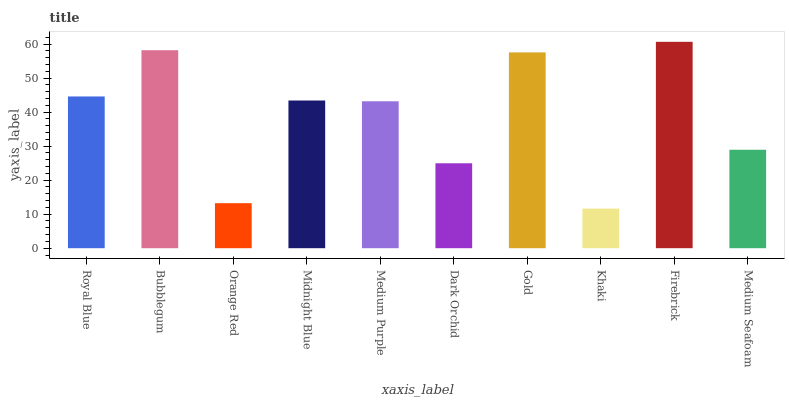Is Khaki the minimum?
Answer yes or no. Yes. Is Firebrick the maximum?
Answer yes or no. Yes. Is Bubblegum the minimum?
Answer yes or no. No. Is Bubblegum the maximum?
Answer yes or no. No. Is Bubblegum greater than Royal Blue?
Answer yes or no. Yes. Is Royal Blue less than Bubblegum?
Answer yes or no. Yes. Is Royal Blue greater than Bubblegum?
Answer yes or no. No. Is Bubblegum less than Royal Blue?
Answer yes or no. No. Is Midnight Blue the high median?
Answer yes or no. Yes. Is Medium Purple the low median?
Answer yes or no. Yes. Is Royal Blue the high median?
Answer yes or no. No. Is Bubblegum the low median?
Answer yes or no. No. 